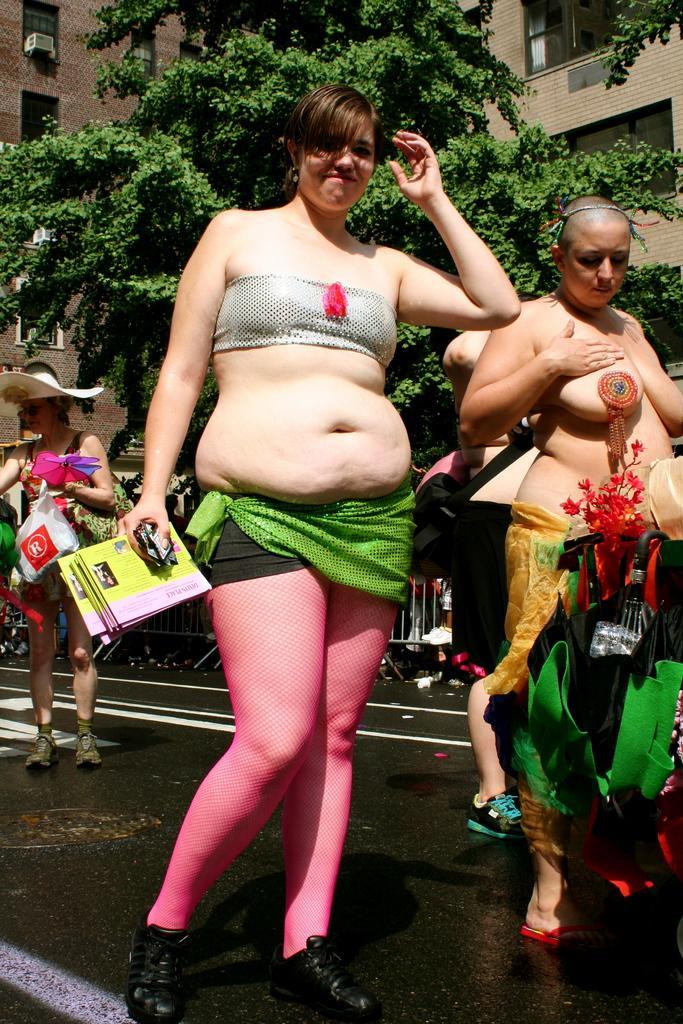How would you summarize this image in a sentence or two? In this picture, we see the women wearing the costumes are standing. The woman in front of the picture is holding the cards in her hands and she is smiling. The woman on the left side who is wearing a hat is standing. At the bottom, we see the road. There are trees and buildings in the background. 